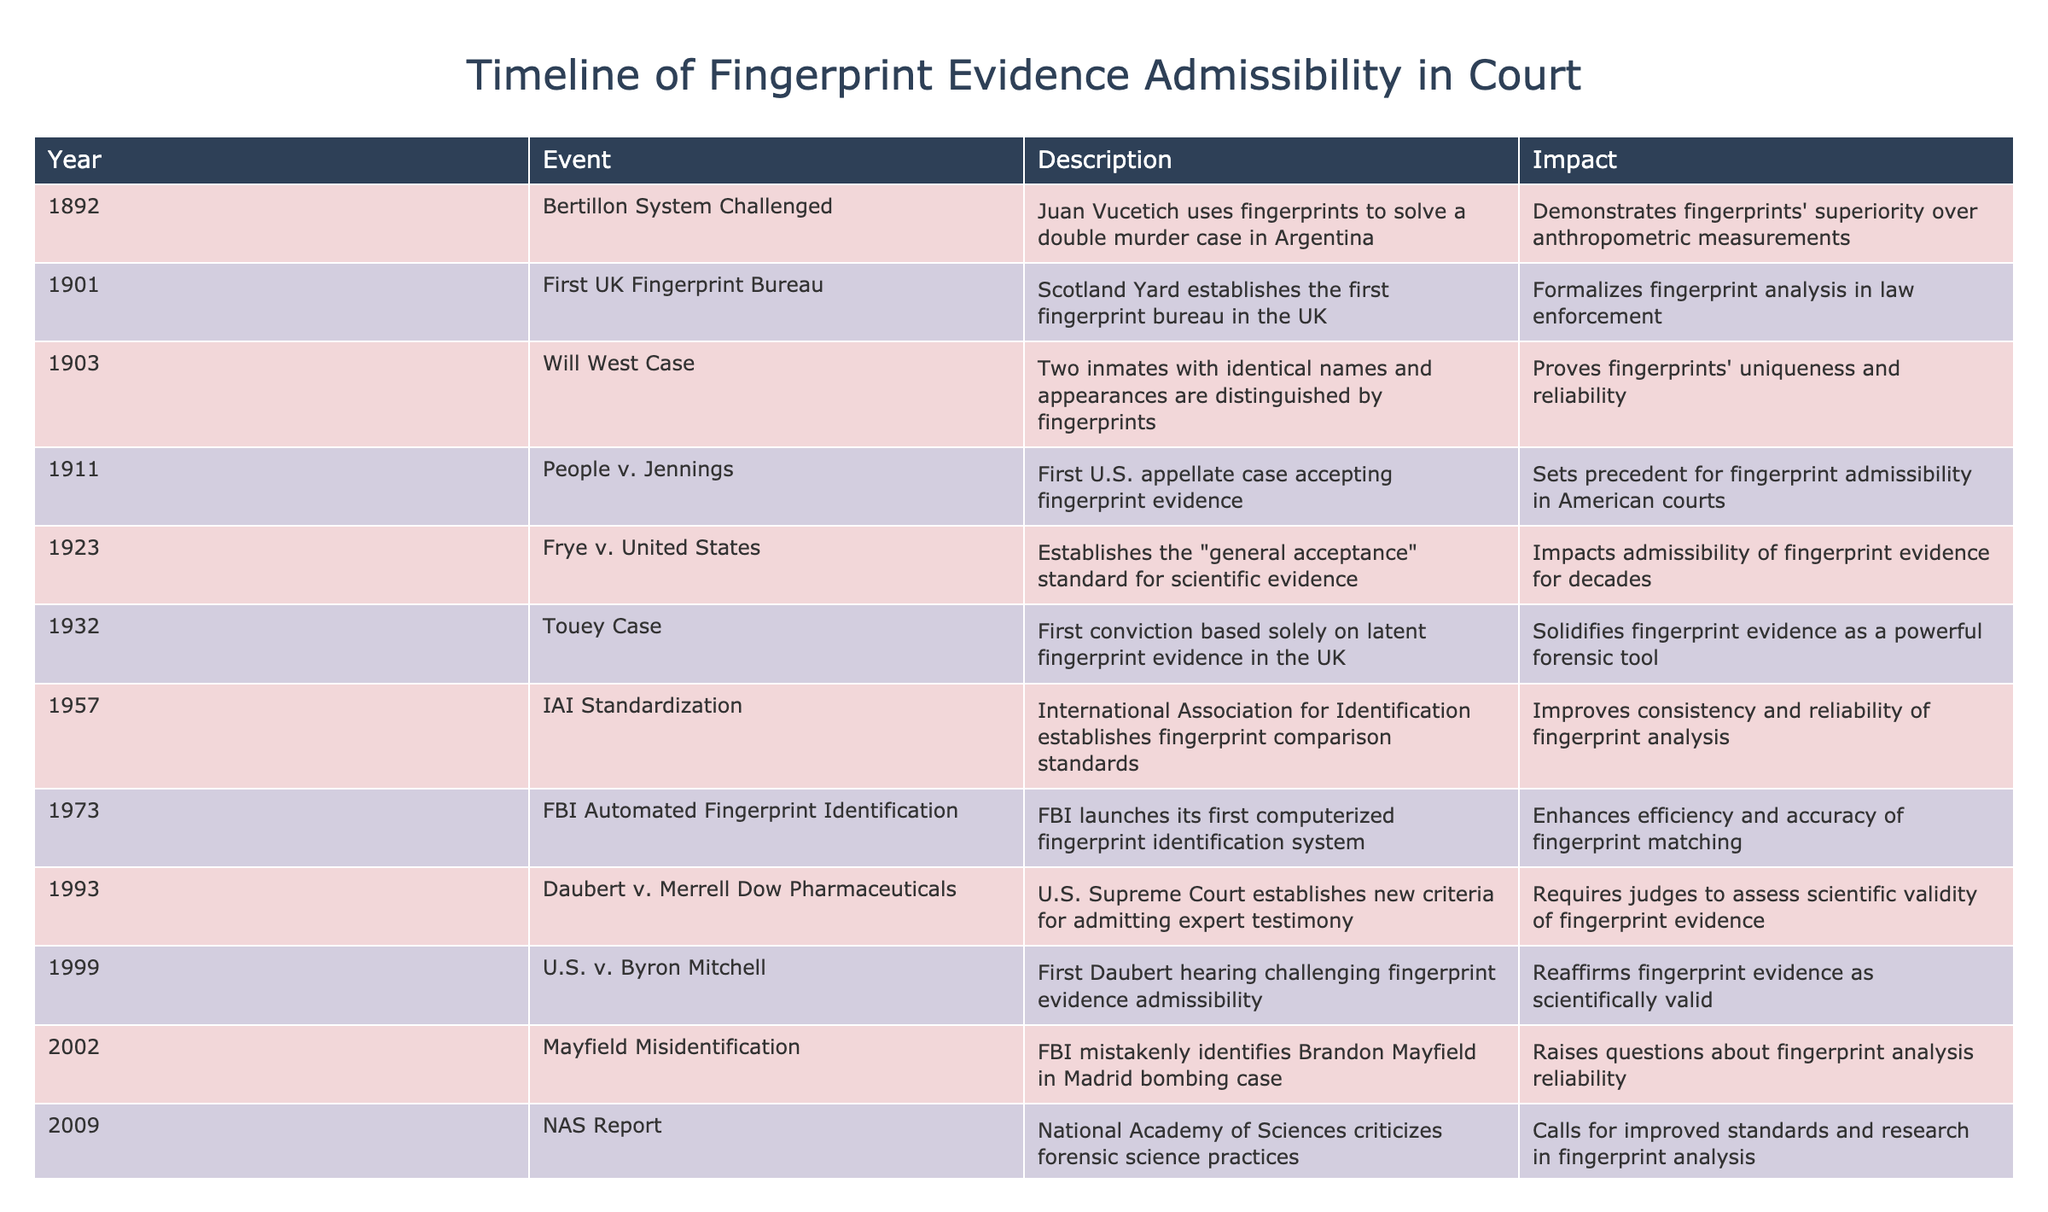What year did the first U.S. appellate case accept fingerprint evidence? The table indicates that the first U.S. appellate case accepting fingerprint evidence occurred in 1911, as noted in the row under that year.
Answer: 1911 Which event demonstrated fingerprints' superiority over anthropometric measurements? The table shows that the event demonstrating fingerprints' superiority was Juan Vucetich using fingerprints to solve a double murder case in Argentina in 1892.
Answer: Bertillon System Challenged in 1892 How many years passed between the establishment of the first fingerprint bureau in the UK and the Frye v. United States case? The first fingerprint bureau in the UK was established in 1901, and the Frye v. United States case occurred in 1923. The difference between these years is 1923 - 1901 = 22 years.
Answer: 22 years Was the FBI's first computerized fingerprint identification system launched before or after the Mayfield misidentification? According to the table, the FBI's first computerized fingerprint identification system was launched in 1973, while the Mayfield misidentification occurred in 2002. Since 1973 is before 2002, the answer is that it was launched before.
Answer: Before Identify one significant impact of the NAS Report in 2009. The data from the table states that the NAS Report criticized forensic science practices and called for improved standards and research in fingerprint analysis.
Answer: Calls for improved standards and research 